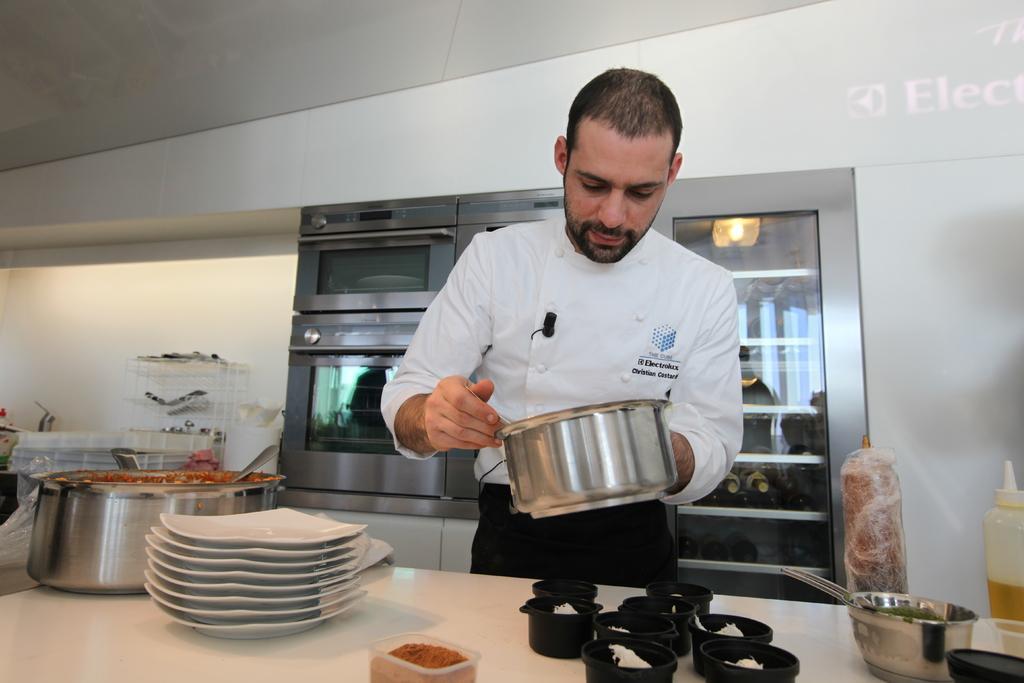Can you describe this image briefly? In this image a person is standing and holding a beaker, a group of plates are placed one on the other ,behind the person we can see a micro oven ,in this image we can see a bottle is placed on the table. 